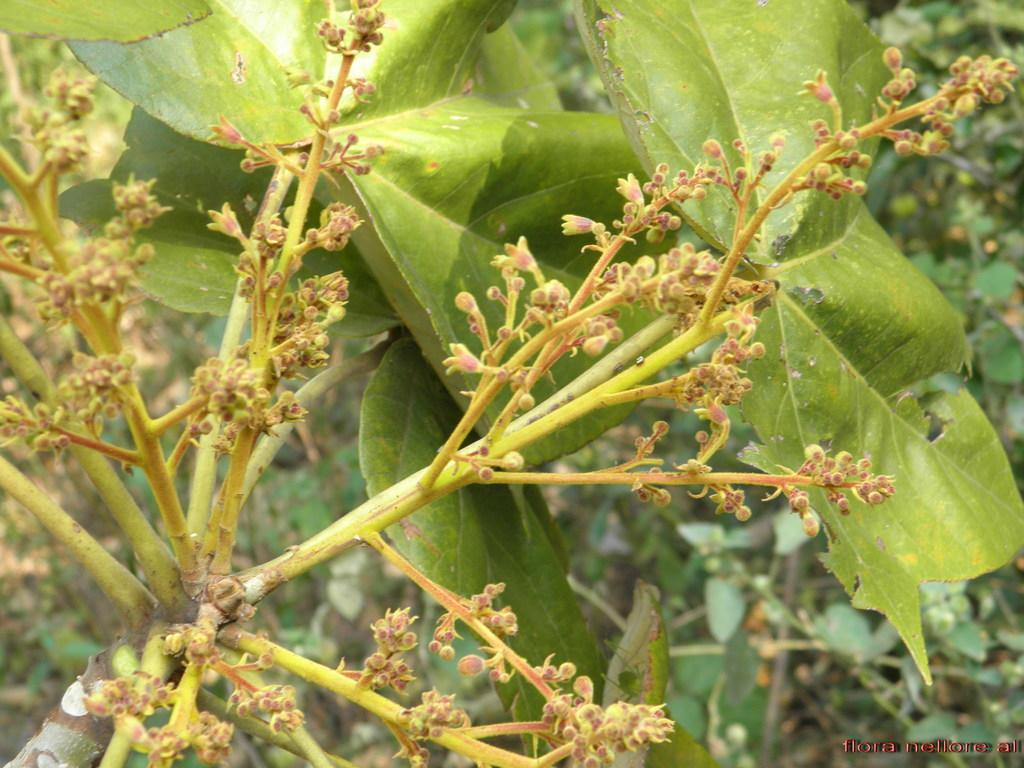What type of living organisms can be seen in the image? Plants can be seen in the image. Where is the text located in the image? The text is at the bottom right side of the image. What is the chance of ants being present in the image? There is no information about ants in the image, so it cannot be determined from the picture. 